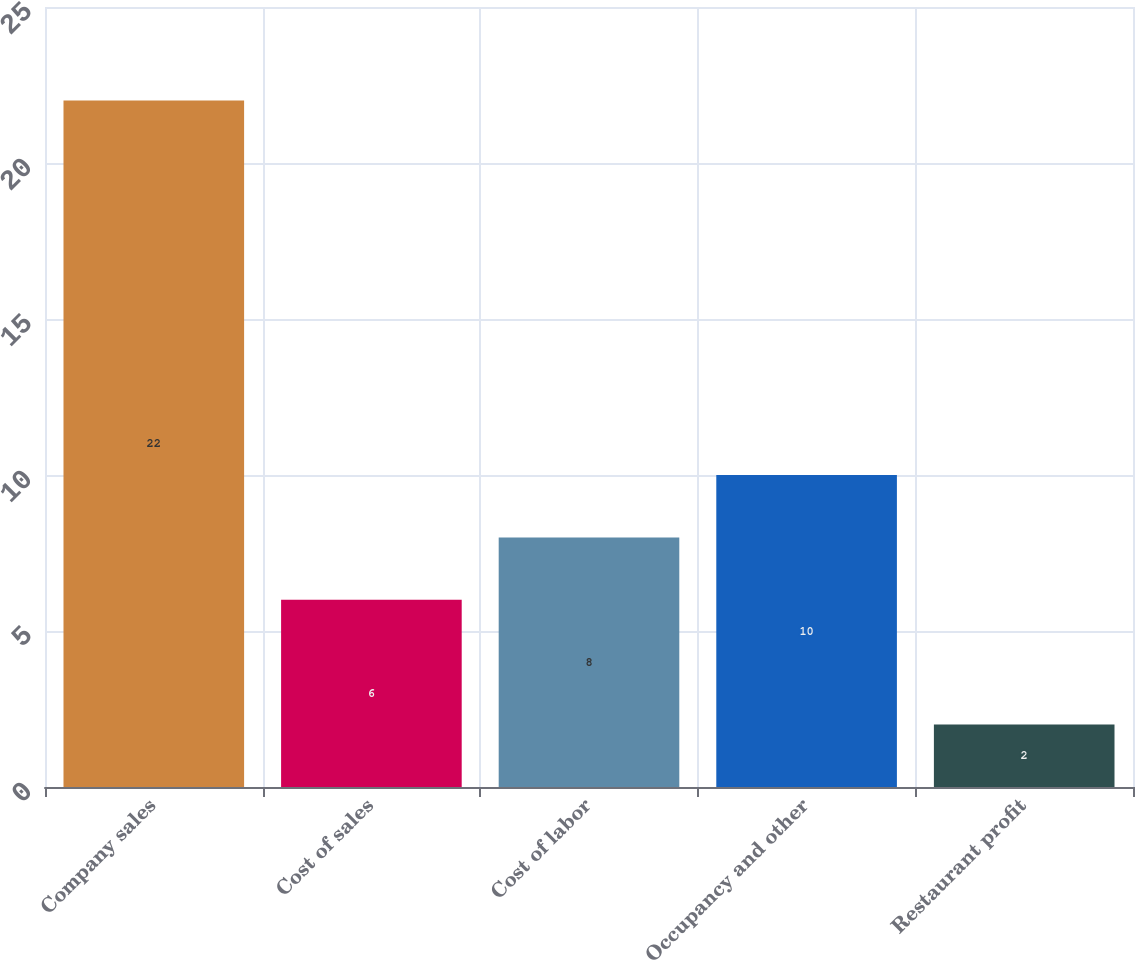Convert chart to OTSL. <chart><loc_0><loc_0><loc_500><loc_500><bar_chart><fcel>Company sales<fcel>Cost of sales<fcel>Cost of labor<fcel>Occupancy and other<fcel>Restaurant profit<nl><fcel>22<fcel>6<fcel>8<fcel>10<fcel>2<nl></chart> 